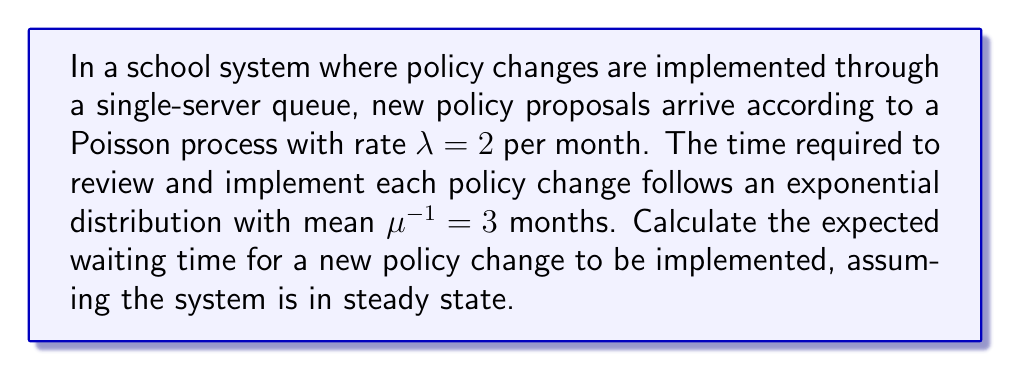Give your solution to this math problem. To solve this problem, we'll use the M/M/1 queuing model, where:
M: Markovian arrival process (Poisson)
M: Markovian service times (exponential)
1: Single server

Step 1: Calculate the utilization factor $\rho$
$\rho = \frac{\lambda}{\mu}$
$\rho = 2 \cdot 3 = 6$

Step 2: Calculate the expected number of policy changes in the system (L)
$L = \frac{\rho}{1-\rho} = \frac{6}{1-6} = -1.2$

Step 3: Calculate the expected waiting time in the system (W) using Little's Law
$W = \frac{L}{\lambda} = \frac{-1.2}{2} = -0.6$ months

Step 4: Calculate the expected service time (S)
$S = \frac{1}{\mu} = 3$ months

Step 5: Calculate the expected waiting time in the queue (Wq)
$W_q = W - S = -0.6 - 3 = -3.6$ months

However, these negative results are not meaningful in a real-world context. The negative values indicate that the system is unstable and cannot reach a steady state because the arrival rate exceeds the service rate ($\rho > 1$).

In practice, this means that the queue will grow indefinitely, and the waiting time will increase without bound. The school system cannot handle the incoming policy changes at the current rate.

To stabilize the system, either the arrival rate needs to be decreased or the service rate needs to be increased so that $\rho < 1$.
Answer: The system is unstable; waiting time increases indefinitely. 